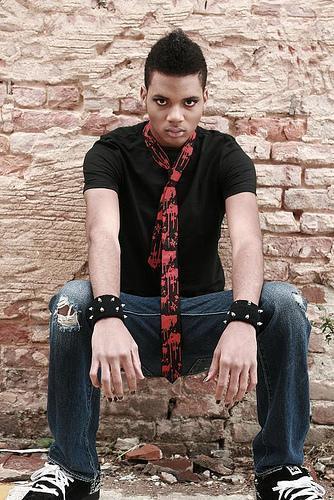How many people are in the picture?
Give a very brief answer. 1. 